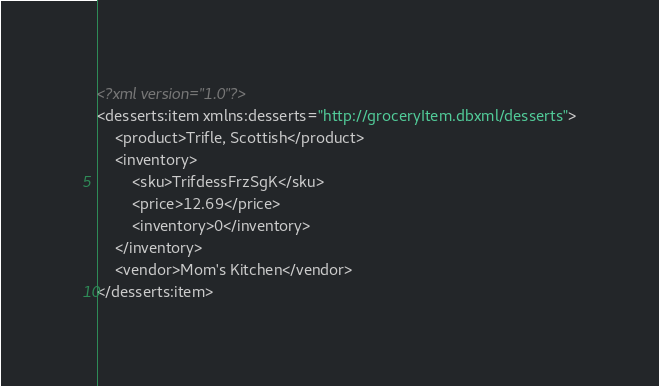Convert code to text. <code><loc_0><loc_0><loc_500><loc_500><_XML_><?xml version="1.0"?>
<desserts:item xmlns:desserts="http://groceryItem.dbxml/desserts">
	<product>Trifle, Scottish</product>
	<inventory>
		<sku>TrifdessFrzSgK</sku>
		<price>12.69</price>
		<inventory>0</inventory>
	</inventory>
	<vendor>Mom's Kitchen</vendor>
</desserts:item>

</code> 